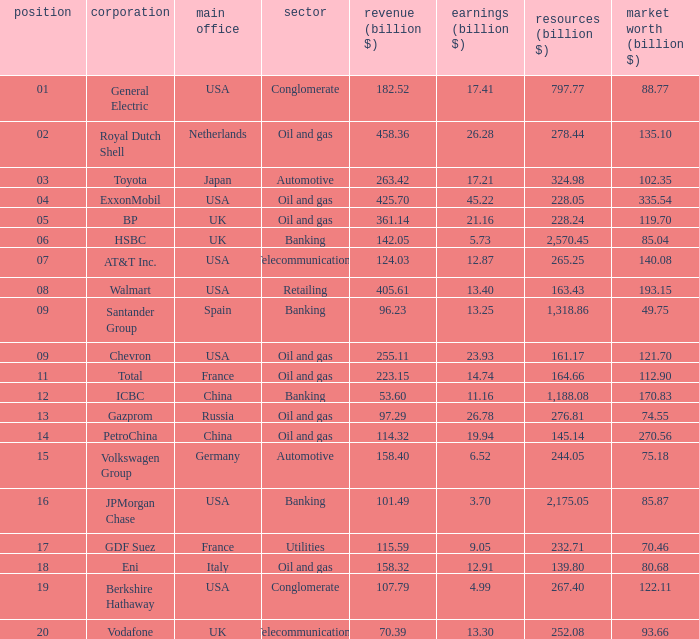How many Assets (billion $) has an Industry of oil and gas, and a Rank of 9, and a Market Value (billion $) larger than 121.7? None. 